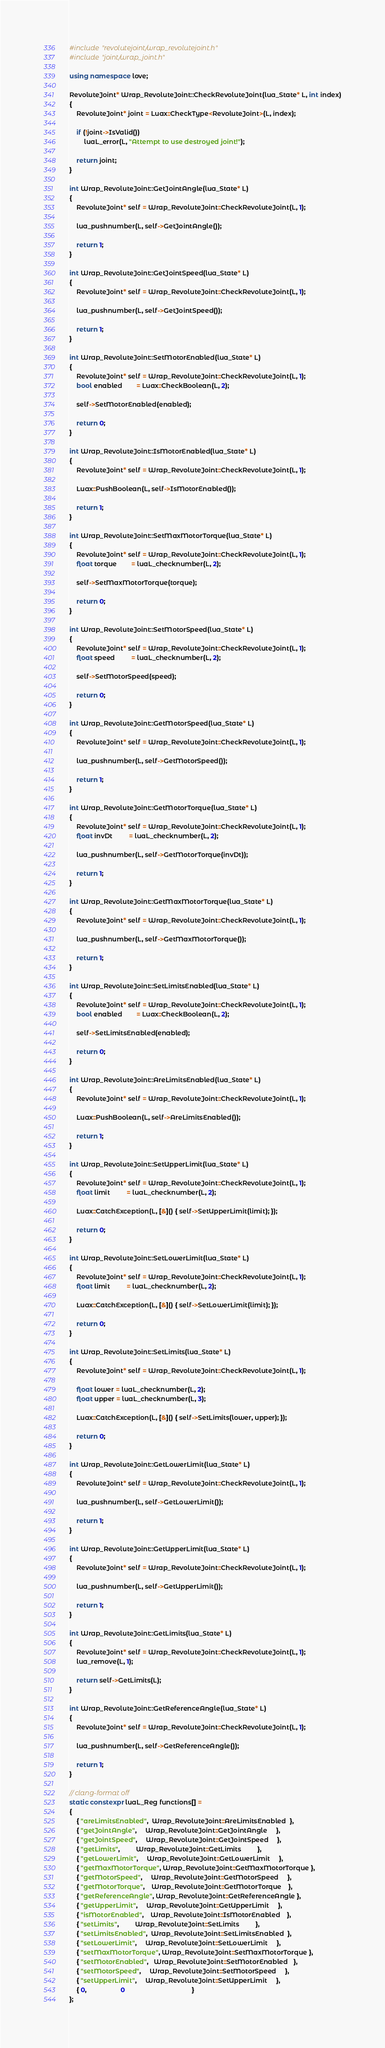<code> <loc_0><loc_0><loc_500><loc_500><_C++_>#include "revolutejoint/wrap_revolutejoint.h"
#include "joint/wrap_joint.h"

using namespace love;

RevoluteJoint* Wrap_RevoluteJoint::CheckRevoluteJoint(lua_State* L, int index)
{
    RevoluteJoint* joint = Luax::CheckType<RevoluteJoint>(L, index);

    if (!joint->IsValid())
        luaL_error(L, "Attempt to use destroyed joint!");

    return joint;
}

int Wrap_RevoluteJoint::GetJointAngle(lua_State* L)
{
    RevoluteJoint* self = Wrap_RevoluteJoint::CheckRevoluteJoint(L, 1);

    lua_pushnumber(L, self->GetJointAngle());

    return 1;
}

int Wrap_RevoluteJoint::GetJointSpeed(lua_State* L)
{
    RevoluteJoint* self = Wrap_RevoluteJoint::CheckRevoluteJoint(L, 1);

    lua_pushnumber(L, self->GetJointSpeed());

    return 1;
}

int Wrap_RevoluteJoint::SetMotorEnabled(lua_State* L)
{
    RevoluteJoint* self = Wrap_RevoluteJoint::CheckRevoluteJoint(L, 1);
    bool enabled        = Luax::CheckBoolean(L, 2);

    self->SetMotorEnabled(enabled);

    return 0;
}

int Wrap_RevoluteJoint::IsMotorEnabled(lua_State* L)
{
    RevoluteJoint* self = Wrap_RevoluteJoint::CheckRevoluteJoint(L, 1);

    Luax::PushBoolean(L, self->IsMotorEnabled());

    return 1;
}

int Wrap_RevoluteJoint::SetMaxMotorTorque(lua_State* L)
{
    RevoluteJoint* self = Wrap_RevoluteJoint::CheckRevoluteJoint(L, 1);
    float torque        = luaL_checknumber(L, 2);

    self->SetMaxMotorTorque(torque);

    return 0;
}

int Wrap_RevoluteJoint::SetMotorSpeed(lua_State* L)
{
    RevoluteJoint* self = Wrap_RevoluteJoint::CheckRevoluteJoint(L, 1);
    float speed         = luaL_checknumber(L, 2);

    self->SetMotorSpeed(speed);

    return 0;
}

int Wrap_RevoluteJoint::GetMotorSpeed(lua_State* L)
{
    RevoluteJoint* self = Wrap_RevoluteJoint::CheckRevoluteJoint(L, 1);

    lua_pushnumber(L, self->GetMotorSpeed());

    return 1;
}

int Wrap_RevoluteJoint::GetMotorTorque(lua_State* L)
{
    RevoluteJoint* self = Wrap_RevoluteJoint::CheckRevoluteJoint(L, 1);
    float invDt         = luaL_checknumber(L, 2);

    lua_pushnumber(L, self->GetMotorTorque(invDt));

    return 1;
}

int Wrap_RevoluteJoint::GetMaxMotorTorque(lua_State* L)
{
    RevoluteJoint* self = Wrap_RevoluteJoint::CheckRevoluteJoint(L, 1);

    lua_pushnumber(L, self->GetMaxMotorTorque());

    return 1;
}

int Wrap_RevoluteJoint::SetLimitsEnabled(lua_State* L)
{
    RevoluteJoint* self = Wrap_RevoluteJoint::CheckRevoluteJoint(L, 1);
    bool enabled        = Luax::CheckBoolean(L, 2);

    self->SetLimitsEnabled(enabled);

    return 0;
}

int Wrap_RevoluteJoint::AreLimitsEnabled(lua_State* L)
{
    RevoluteJoint* self = Wrap_RevoluteJoint::CheckRevoluteJoint(L, 1);

    Luax::PushBoolean(L, self->AreLimitsEnabled());

    return 1;
}

int Wrap_RevoluteJoint::SetUpperLimit(lua_State* L)
{
    RevoluteJoint* self = Wrap_RevoluteJoint::CheckRevoluteJoint(L, 1);
    float limit         = luaL_checknumber(L, 2);

    Luax::CatchException(L, [&]() { self->SetUpperLimit(limit); });

    return 0;
}

int Wrap_RevoluteJoint::SetLowerLimit(lua_State* L)
{
    RevoluteJoint* self = Wrap_RevoluteJoint::CheckRevoluteJoint(L, 1);
    float limit         = luaL_checknumber(L, 2);

    Luax::CatchException(L, [&]() { self->SetLowerLimit(limit); });

    return 0;
}

int Wrap_RevoluteJoint::SetLimits(lua_State* L)
{
    RevoluteJoint* self = Wrap_RevoluteJoint::CheckRevoluteJoint(L, 1);

    float lower = luaL_checknumber(L, 2);
    float upper = luaL_checknumber(L, 3);

    Luax::CatchException(L, [&]() { self->SetLimits(lower, upper); });

    return 0;
}

int Wrap_RevoluteJoint::GetLowerLimit(lua_State* L)
{
    RevoluteJoint* self = Wrap_RevoluteJoint::CheckRevoluteJoint(L, 1);

    lua_pushnumber(L, self->GetLowerLimit());

    return 1;
}

int Wrap_RevoluteJoint::GetUpperLimit(lua_State* L)
{
    RevoluteJoint* self = Wrap_RevoluteJoint::CheckRevoluteJoint(L, 1);

    lua_pushnumber(L, self->GetUpperLimit());

    return 1;
}

int Wrap_RevoluteJoint::GetLimits(lua_State* L)
{
    RevoluteJoint* self = Wrap_RevoluteJoint::CheckRevoluteJoint(L, 1);
    lua_remove(L, 1);

    return self->GetLimits(L);
}

int Wrap_RevoluteJoint::GetReferenceAngle(lua_State* L)
{
    RevoluteJoint* self = Wrap_RevoluteJoint::CheckRevoluteJoint(L, 1);

    lua_pushnumber(L, self->GetReferenceAngle());

    return 1;
}

// clang-format off
static constexpr luaL_Reg functions[] =
{
    { "areLimitsEnabled",  Wrap_RevoluteJoint::AreLimitsEnabled  },
    { "getJointAngle",     Wrap_RevoluteJoint::GetJointAngle     },
    { "getJointSpeed",     Wrap_RevoluteJoint::GetJointSpeed     },
    { "getLimits",         Wrap_RevoluteJoint::GetLimits         },
    { "getLowerLimit",     Wrap_RevoluteJoint::GetLowerLimit     },
    { "getMaxMotorTorque", Wrap_RevoluteJoint::GetMaxMotorTorque },
    { "getMotorSpeed",     Wrap_RevoluteJoint::GetMotorSpeed     },
    { "getMotorTorque",    Wrap_RevoluteJoint::GetMotorTorque    },
    { "getReferenceAngle", Wrap_RevoluteJoint::GetReferenceAngle },
    { "getUpperLimit",     Wrap_RevoluteJoint::GetUpperLimit     },
    { "isMotorEnabled",    Wrap_RevoluteJoint::IsMotorEnabled    },
    { "setLimits",         Wrap_RevoluteJoint::SetLimits         },
    { "setLimitsEnabled",  Wrap_RevoluteJoint::SetLimitsEnabled  },
    { "setLowerLimit",     Wrap_RevoluteJoint::SetLowerLimit     },
    { "setMaxMotorTorque", Wrap_RevoluteJoint::SetMaxMotorTorque },
    { "setMotorEnabled",   Wrap_RevoluteJoint::SetMotorEnabled   },
    { "setMotorSpeed",     Wrap_RevoluteJoint::SetMotorSpeed     },
    { "setUpperLimit",     Wrap_RevoluteJoint::SetUpperLimit     },
    { 0,                   0                                     }
};</code> 